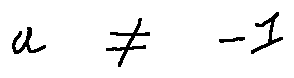<formula> <loc_0><loc_0><loc_500><loc_500>a \neq - 1</formula> 